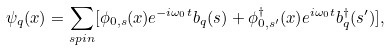<formula> <loc_0><loc_0><loc_500><loc_500>\psi _ { q } ( x ) = \sum _ { s p i n } [ \phi _ { 0 , s } ( { x } ) e ^ { - i \omega _ { 0 } t } b _ { q } ( s ) + \phi _ { 0 , s ^ { \prime } } ^ { \dagger } ( { x } ) e ^ { i \omega _ { 0 } t } b _ { q } ^ { \dagger } ( s ^ { \prime } ) ] ,</formula> 